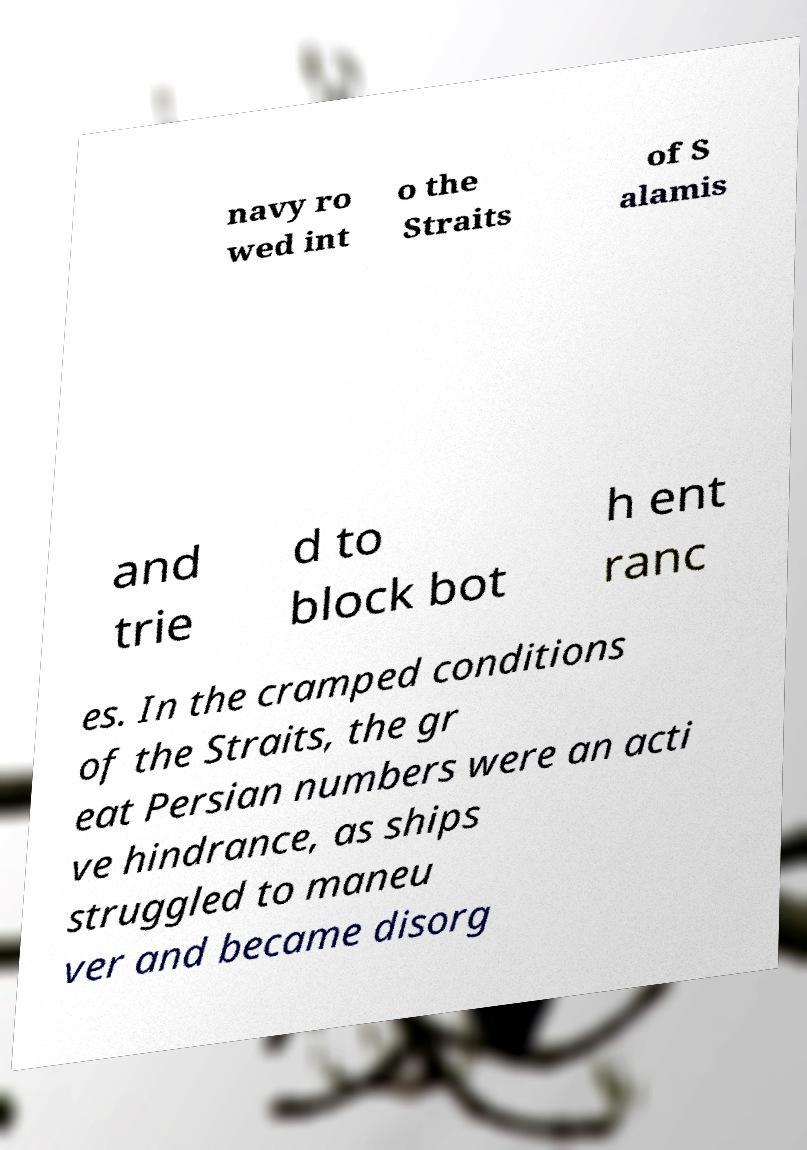There's text embedded in this image that I need extracted. Can you transcribe it verbatim? navy ro wed int o the Straits of S alamis and trie d to block bot h ent ranc es. In the cramped conditions of the Straits, the gr eat Persian numbers were an acti ve hindrance, as ships struggled to maneu ver and became disorg 